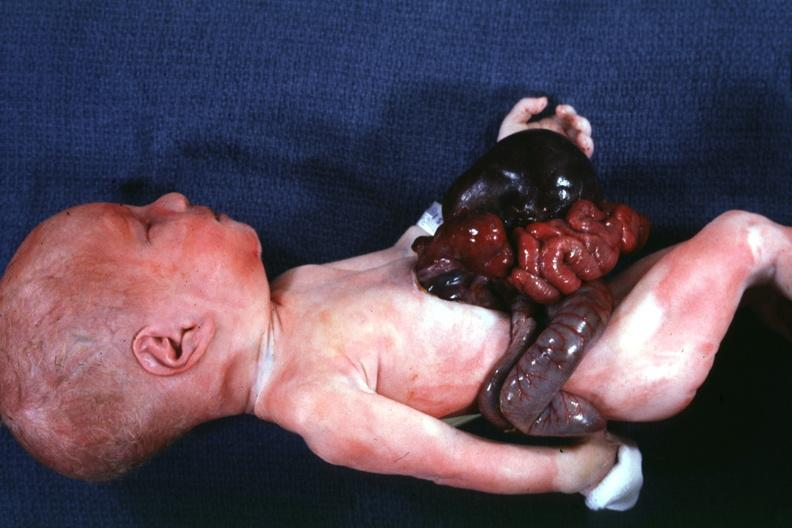s omphalocele present?
Answer the question using a single word or phrase. Yes 